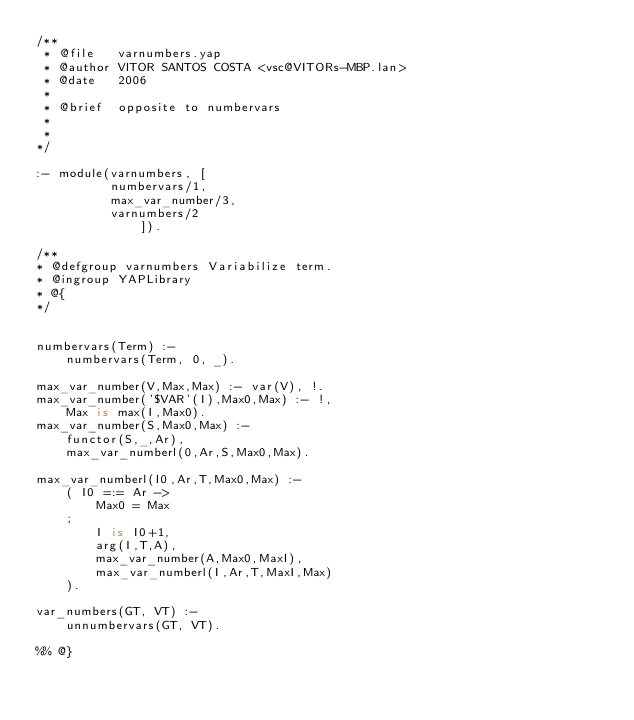Convert code to text. <code><loc_0><loc_0><loc_500><loc_500><_Prolog_>/**
 * @file   varnumbers.yap
 * @author VITOR SANTOS COSTA <vsc@VITORs-MBP.lan>
 * @date   2006
 *
 * @brief  opposite to numbervars
 *
 *
*/

:- module(varnumbers, [
		  numbervars/1,
		  max_var_number/3,
		  varnumbers/2
              ]).

/**
* @defgroup varnumbers Variabilize term.
* @ingroup YAPLibrary
* @{
*/


numbervars(Term) :-
	numbervars(Term, 0, _).

max_var_number(V,Max,Max) :- var(V), !.
max_var_number('$VAR'(I),Max0,Max) :- !,
	Max is max(I,Max0).
max_var_number(S,Max0,Max) :-
	functor(S,_,Ar),
	max_var_numberl(0,Ar,S,Max0,Max).

max_var_numberl(I0,Ar,T,Max0,Max) :-
	( I0 =:= Ar ->
	    Max0 = Max
	;
	    I is I0+1,
	    arg(I,T,A),
	    max_var_number(A,Max0,MaxI),
	    max_var_numberl(I,Ar,T,MaxI,Max)
	).

var_numbers(GT, VT) :-
	unnumbervars(GT, VT).

%% @}
</code> 